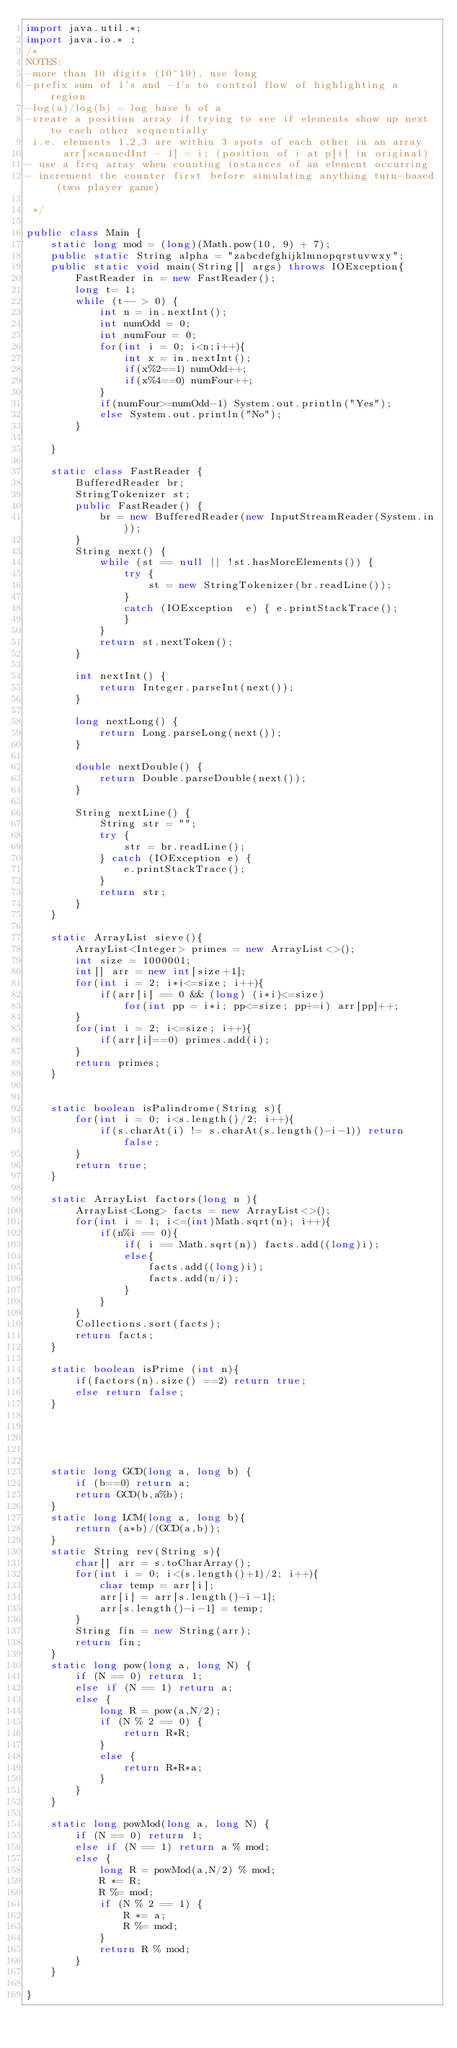<code> <loc_0><loc_0><loc_500><loc_500><_Java_>import java.util.*;
import java.io.* ;
/*
NOTES:
-more than 10 digits (10^10), use long
-prefix sum of 1's and -1's to control flow of highlighting a region
-log(a)/log(b) = log base b of a
-create a position array if trying to see if elements show up next to each other sequentially
 i.e. elements 1,2,3 are within 3 spots of each other in an array
      arr[scannedInt - 1] = i; (position of i at p[i] in original)
- use a freq array when counting instances of an element occurring
- increment the counter first before simulating anything turn-based (two player game)

 */

public class Main {
    static long mod = (long)(Math.pow(10, 9) + 7);
    public static String alpha = "zabcdefghijklmnopqrstuvwxy";
    public static void main(String[] args) throws IOException{
        FastReader in = new FastReader();
        long t= 1;
        while (t-- > 0) {
            int n = in.nextInt();
            int numOdd = 0;
            int numFour = 0;
            for(int i = 0; i<n;i++){
                int x = in.nextInt();
                if(x%2==1) numOdd++;
                if(x%4==0) numFour++;
            }
            if(numFour>=numOdd-1) System.out.println("Yes");
            else System.out.println("No");
        }

    }

    static class FastReader {
        BufferedReader br;
        StringTokenizer st;
        public FastReader() {
            br = new BufferedReader(new InputStreamReader(System.in));
        }
        String next() {
            while (st == null || !st.hasMoreElements()) {
                try {
                    st = new StringTokenizer(br.readLine());
                }
                catch (IOException  e) { e.printStackTrace();
                }
            }
            return st.nextToken();
        }

        int nextInt() {
            return Integer.parseInt(next());
        }

        long nextLong() {
            return Long.parseLong(next());
        }

        double nextDouble() {
            return Double.parseDouble(next());
        }

        String nextLine() {
            String str = "";
            try {
                str = br.readLine();
            } catch (IOException e) {
                e.printStackTrace();
            }
            return str;
        }
    }

    static ArrayList sieve(){
        ArrayList<Integer> primes = new ArrayList<>();
        int size = 1000001;
        int[] arr = new int[size+1];
        for(int i = 2; i*i<=size; i++){
            if(arr[i] == 0 && (long) (i*i)<=size)
                for(int pp = i*i; pp<=size; pp+=i) arr[pp]++;
        }
        for(int i = 2; i<=size; i++){
            if(arr[i]==0) primes.add(i);
        }
        return primes;
    }


    static boolean isPalindrome(String s){
        for(int i = 0; i<s.length()/2; i++){
            if(s.charAt(i) != s.charAt(s.length()-i-1)) return false;
        }
        return true;
    }

    static ArrayList factors(long n ){
        ArrayList<Long> facts = new ArrayList<>();
        for(int i = 1; i<=(int)Math.sqrt(n); i++){
            if(n%i == 0){
                if( i == Math.sqrt(n)) facts.add((long)i);
                else{
                    facts.add((long)i);
                    facts.add(n/i);
                }
            }
        }
        Collections.sort(facts);
        return facts;
    }

    static boolean isPrime (int n){
        if(factors(n).size() ==2) return true;
        else return false;
    }





    static long GCD(long a, long b) {
        if (b==0) return a;
        return GCD(b,a%b);
    }
    static long LCM(long a, long b){
        return (a*b)/(GCD(a,b));
    }
    static String rev(String s){
        char[] arr = s.toCharArray();
        for(int i = 0; i<(s.length()+1)/2; i++){
            char temp = arr[i];
            arr[i] = arr[s.length()-i-1];
            arr[s.length()-i-1] = temp;
        }
        String fin = new String(arr);
        return fin;
    }
    static long pow(long a, long N) {
        if (N == 0) return 1;
        else if (N == 1) return a;
        else {
            long R = pow(a,N/2);
            if (N % 2 == 0) {
                return R*R;
            }
            else {
                return R*R*a;
            }
        }
    }

    static long powMod(long a, long N) {
        if (N == 0) return 1;
        else if (N == 1) return a % mod;
        else {
            long R = powMod(a,N/2) % mod;
            R *= R;
            R %= mod;
            if (N % 2 == 1) {
                R *= a;
                R %= mod;
            }
            return R % mod;
        }
    }

}

</code> 